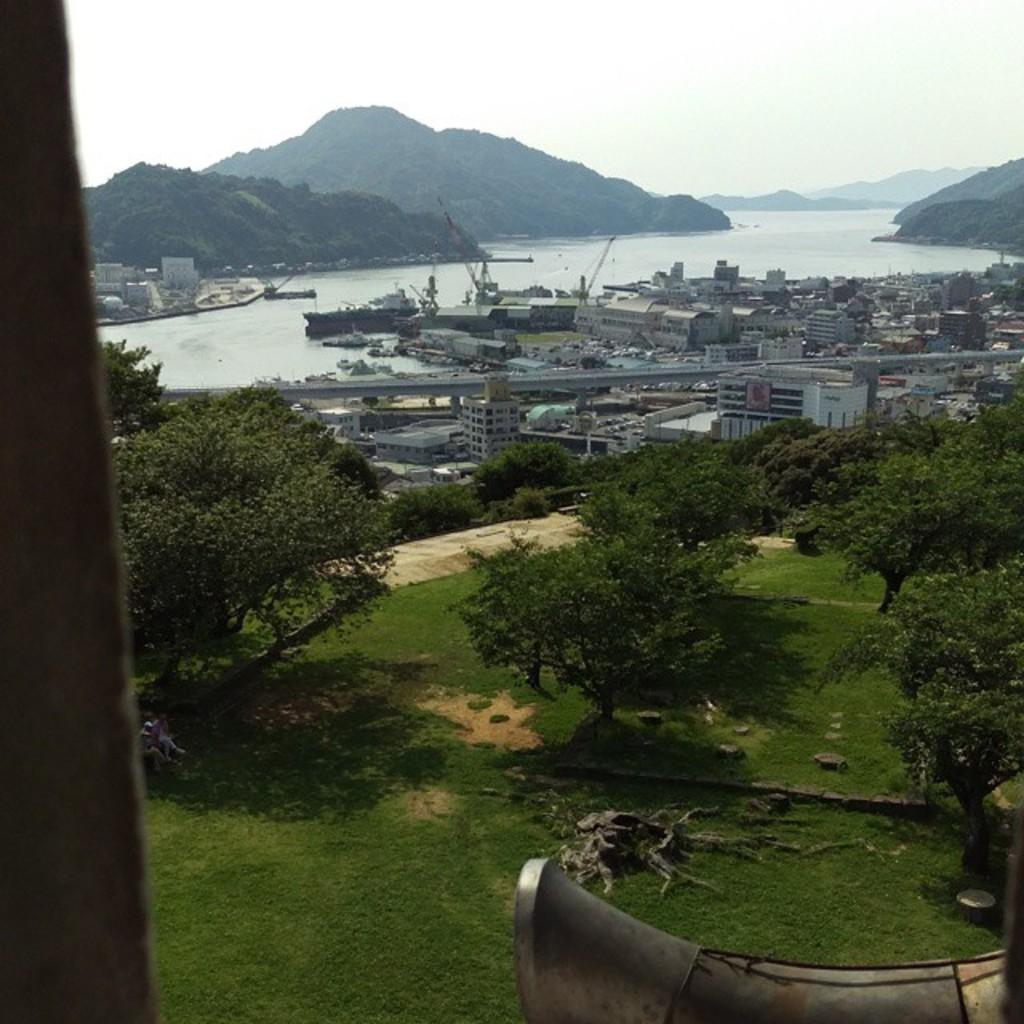What is the main structure in the image? There is a pillar in the image. What is located in front of the pillar? There are trees in front of the pillar. What object is in front of the trees? There is an object in front of the trees, but the specific object is not mentioned in the facts. What type of structures can be seen in the image? There are buildings in the image. What mode of transportation is present in the image? There is a ship in the image. What natural feature is visible in the image? There are mountains in the image. What part of the natural environment is visible in the image? The sky is visible in the image. What type of teeth can be seen on the ship in the image? There are no teeth visible on the ship in the image. 